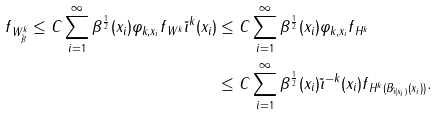<formula> <loc_0><loc_0><loc_500><loc_500>\| f \| _ { W ^ { k } _ { \tilde { \beta } } } \leq C \sum _ { i = 1 } ^ { \infty } \beta ^ { \frac { 1 } { 2 } } ( x _ { i } ) \| \varphi _ { k , x _ { i } } f \| _ { W ^ { k } } \tilde { \imath } ^ { k } ( x _ { i } ) & \leq C \sum _ { i = 1 } ^ { \infty } \beta ^ { \frac { 1 } { 2 } } ( x _ { i } ) \| \varphi _ { k , x _ { i } } f \| _ { H ^ { k } } \\ & \leq C \sum _ { i = 1 } ^ { \infty } \beta ^ { \frac { 1 } { 2 } } ( x _ { i } ) \tilde { \imath } ^ { - k } ( x _ { i } ) \| f \| _ { H ^ { k } ( { B _ { \tilde { \imath } ( x _ { i } ) } ( x _ { i } ) } ) } .</formula> 